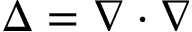<formula> <loc_0><loc_0><loc_500><loc_500>\Delta = \nabla \cdot \nabla</formula> 